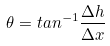Convert formula to latex. <formula><loc_0><loc_0><loc_500><loc_500>\theta = t a n ^ { - 1 } \frac { \Delta h } { \Delta x }</formula> 